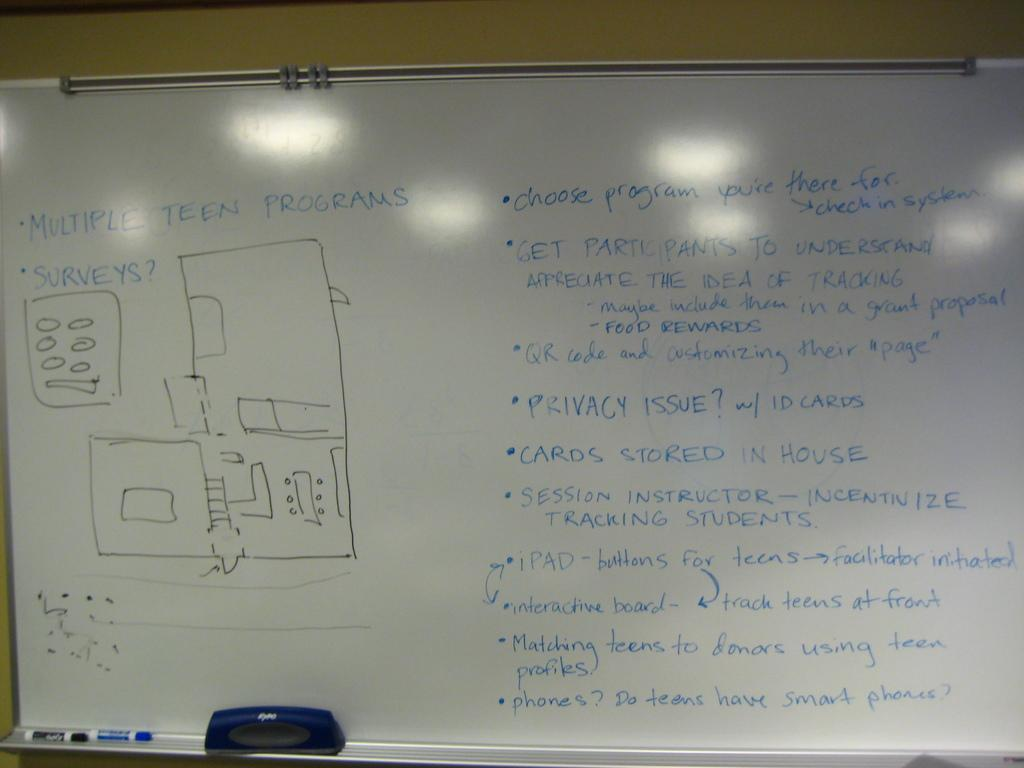<image>
Relay a brief, clear account of the picture shown. A white board with a few diagrams and writing on "Multiple Teen Programs" in order to get students to participate in tracking. 